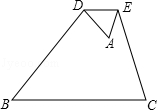How would the area of the smaller triangle ADE compare to the area of the larger triangle ABC? The area of triangle ADE is proportionally smaller than the area of triangle ABC due to their similarity. The ratio of their areas is the square of the ratio of their corresponding sides. Given that DE/BC = 1/4, the ratio of the areas is (1/4)^2, meaning the area of ADE is 1/16 the area of ABC. 